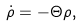<formula> <loc_0><loc_0><loc_500><loc_500>\dot { \rho } = - \Theta \rho ,</formula> 